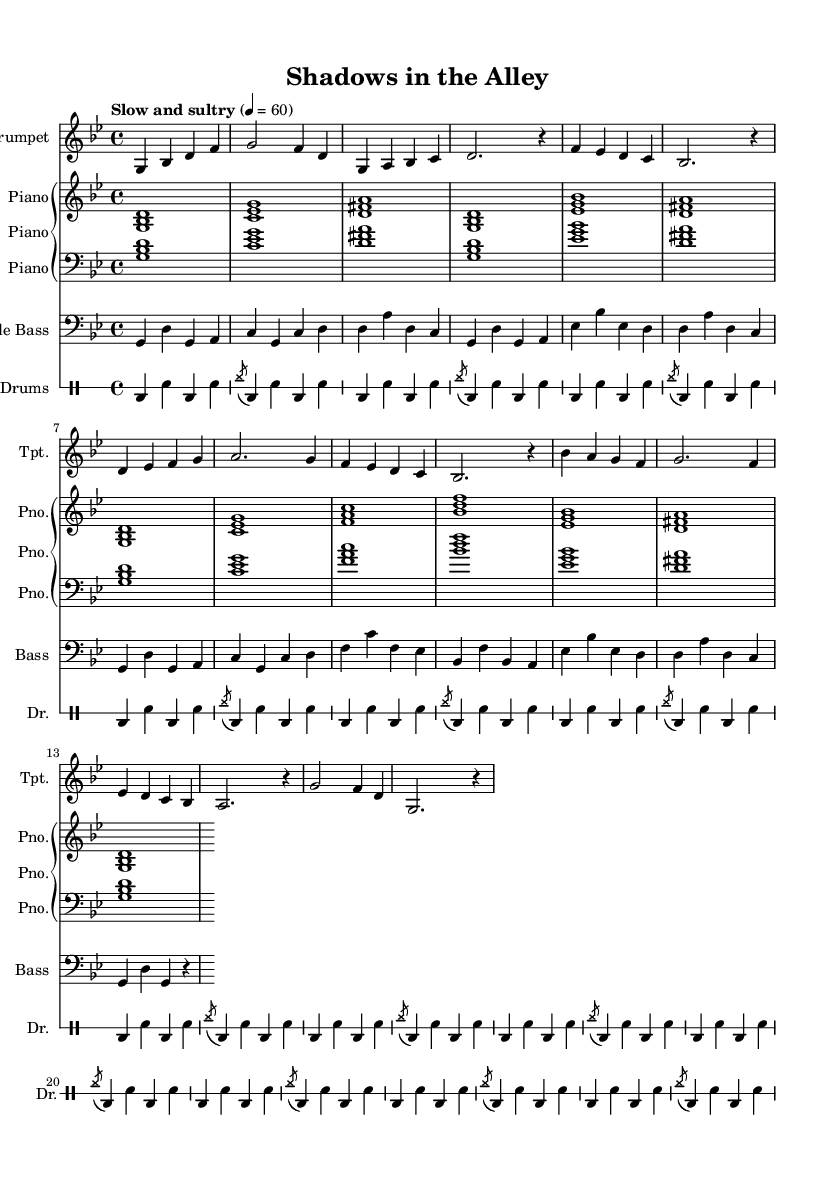What is the key signature of this music? The key signature indicates the presence of two flats, which typically corresponds to the key of G minor. The clef at the beginning shows that the piece is in the treble clef, and the flats are indicated right after the clef.
Answer: G minor What is the time signature of this music? The time signature is displayed immediately after the key signature. In this case, it shows a 4/4 signature, meaning there are four beats in each measure and the quarter note receives one beat.
Answer: 4/4 What is the tempo marking for this piece? The tempo marking, which is written at the beginning of the music, indicates that the piece should be played "Slow and sultry" with a specific beat value. The provided information shows that the tempo is set at 60 beats per minute.
Answer: Slow and sultry What instruments are featured in this composition? The composition includes four distinct instruments, which are indicated at the beginning of each respective part on the score: trumpet, piano, double bass, and drums. This provides a clear indication of the ensemble used in the performance.
Answer: Trumpet, piano, double bass, drums How many sections are there in the trumpet part? Analyzing the structure of the trumpet part shows it is divided into four labeled sections, typically denoted as A, B, and C, along with an intro and an outro section, which altogether adds up to five sections.
Answer: Five What is the primary rhythmic element used in the drums part? Looking at the drums section, the basic rhythmic element consists of a repeating pattern that includes bass drum hits and snare hits combined with an accented hi-hat pattern. This highlights the typical jazz swing feel found in the composition.
Answer: Brush pattern with cymbal accents What is the role of the bass part in this piece? The bass part consists of a walking bass line, which is a common element in jazz music. This line often outlines the chord changes and supports the harmonic progression while maintaining a steady rhythmic foundation for the ensemble.
Answer: Walking bass line 